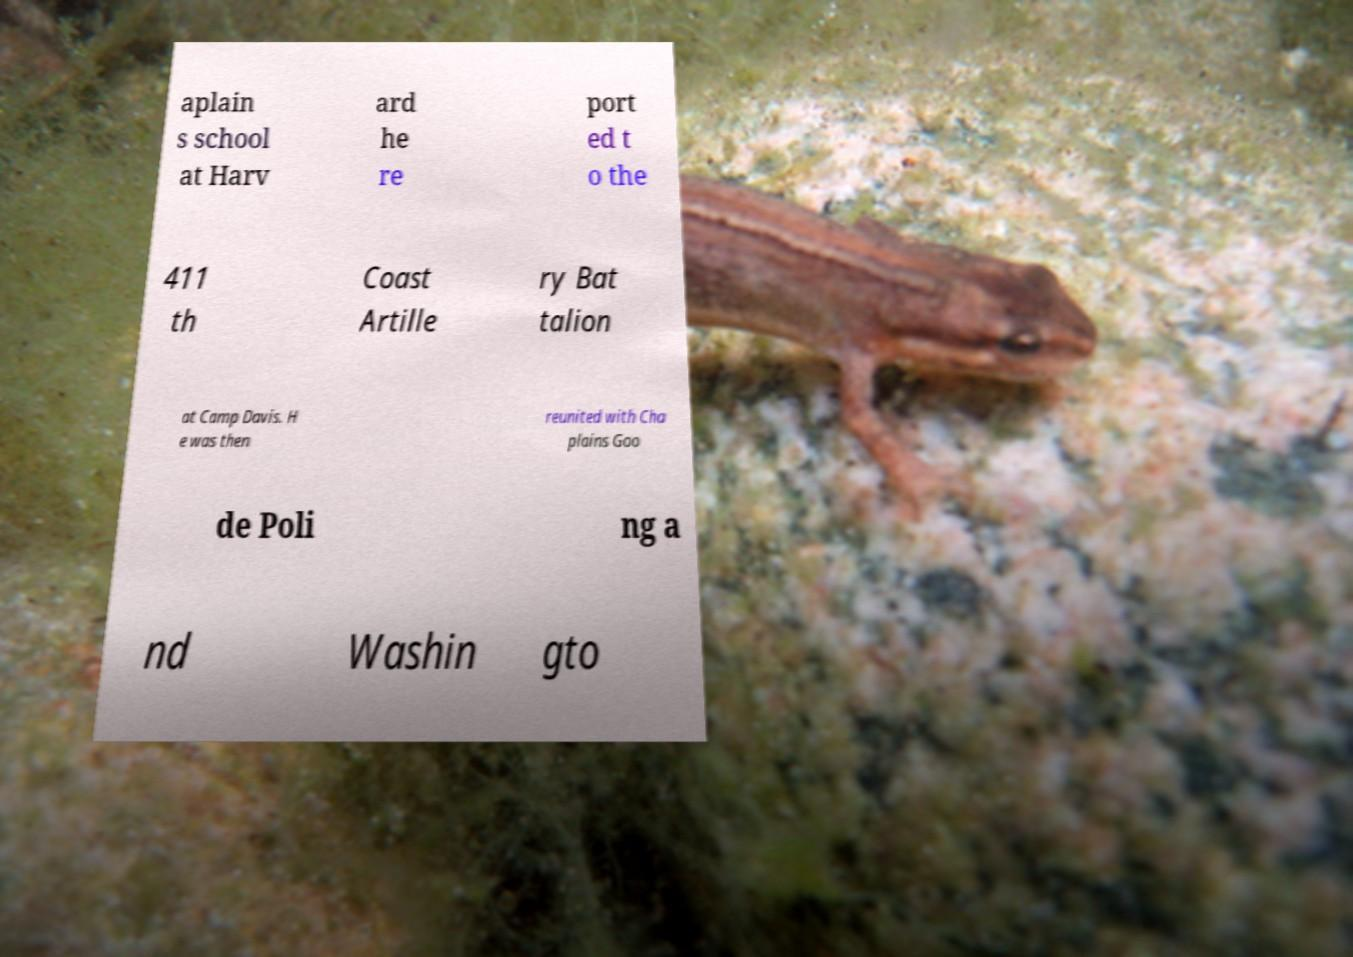I need the written content from this picture converted into text. Can you do that? aplain s school at Harv ard he re port ed t o the 411 th Coast Artille ry Bat talion at Camp Davis. H e was then reunited with Cha plains Goo de Poli ng a nd Washin gto 